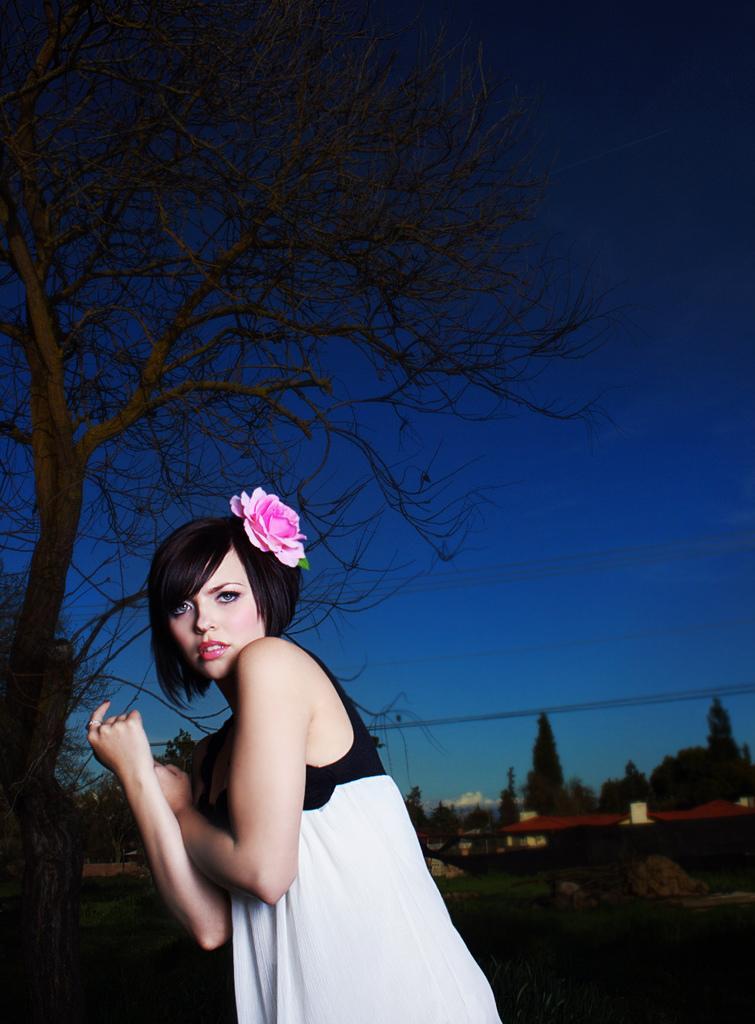How would you summarize this image in a sentence or two? In the center of the image there is a lady. In the background there are trees. At the bottom of the image there is grass. There is sky at the top of the image. 